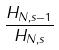<formula> <loc_0><loc_0><loc_500><loc_500>\frac { H _ { N , s - 1 } } { H _ { N , s } }</formula> 